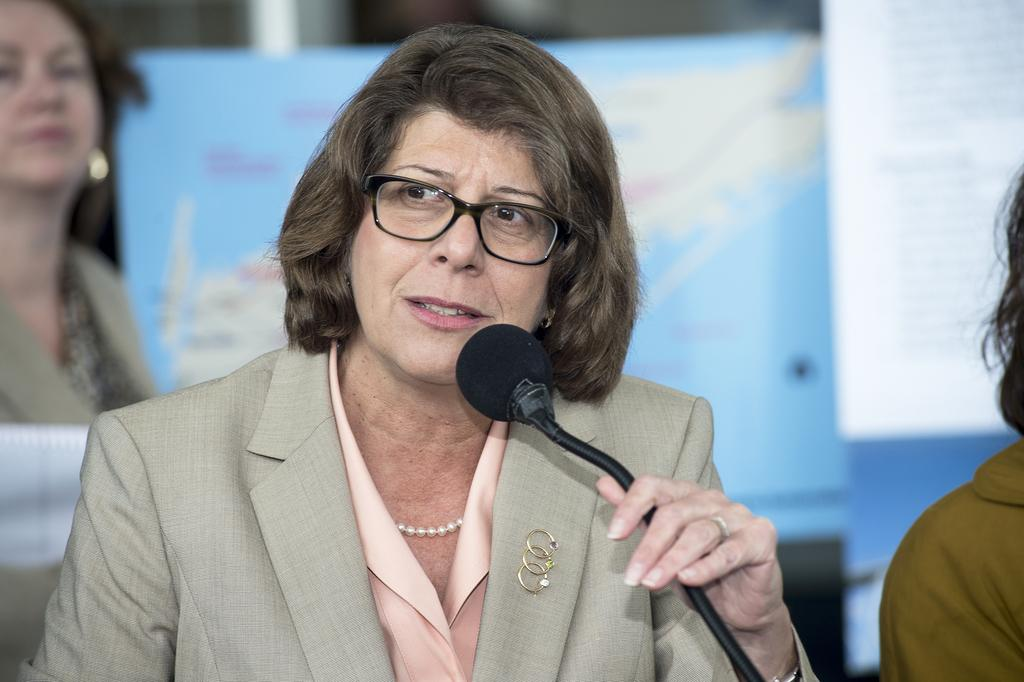Who is the main subject in the image? There is a lady in the image. What is the lady wearing? The lady is wearing a coat, a pearl chain, and specs. What is the lady holding in the image? The lady is holding a mic. What is the lady doing in the image? The lady is speaking. Can you describe the background of the image? A: There is another lady in the background of the image, and there is a banner present. Where is the goldfish swimming in the image? There is no goldfish present in the image. What type of garden can be seen in the background of the image? There is no garden visible in the image; it features a lady speaking with a banner in the background. 